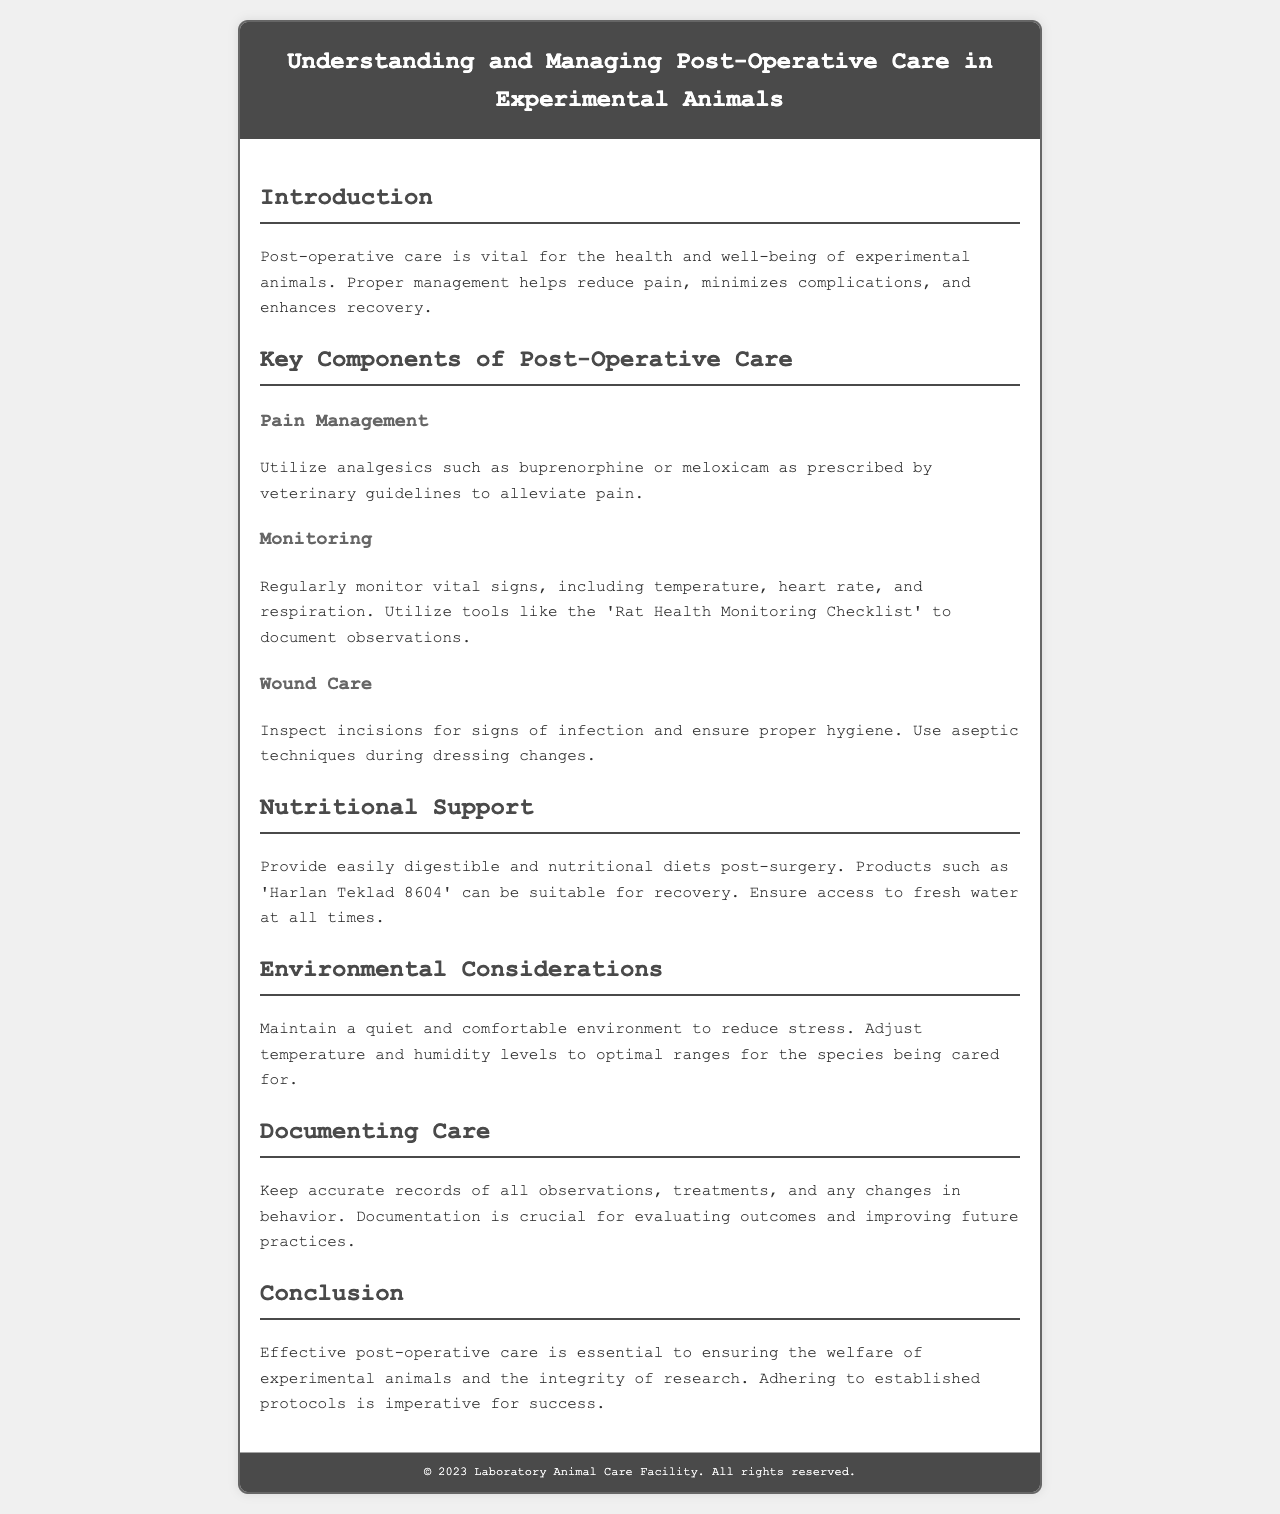What is the title of the brochure? The title is displayed prominently at the top of the document, introducing the main topic.
Answer: Understanding and Managing Post-Operative Care in Experimental Animals What is the purpose of post-operative care? The introduction section explains the significance of post-operative care for experimental animals.
Answer: Health and well-being Which analgesics are mentioned for pain management? The specific analgesics suitable for alleviating pain are listed in the key components section.
Answer: Buprenorphine, meloxicam What should be regularly monitored after surgery? The monitoring section outlines vital signs that need to be checked post-operatively.
Answer: Vital signs What type of diet is recommended for recovery? The nutritional support section specifies the type of diet that should be provided post-surgery.
Answer: Easily digestible and nutritional diets What should be done to ensure proper hygiene for wounds? The text mentions techniques to follow in the wound care section to avoid infection.
Answer: Aseptic techniques How should the environment be maintained post-surgery? The environmental considerations section describes the conditions necessary to reduce stress for the animals.
Answer: Quiet and comfortable Why is documentation critical in post-operative care? The document emphasizes the importance of keeping records for evaluating outcomes.
Answer: Evaluating outcomes What is the concluding message regarding post-operative care? The conclusion section summarizes the significance of adhering to protocols for success in care.
Answer: Welfare of experimental animals 